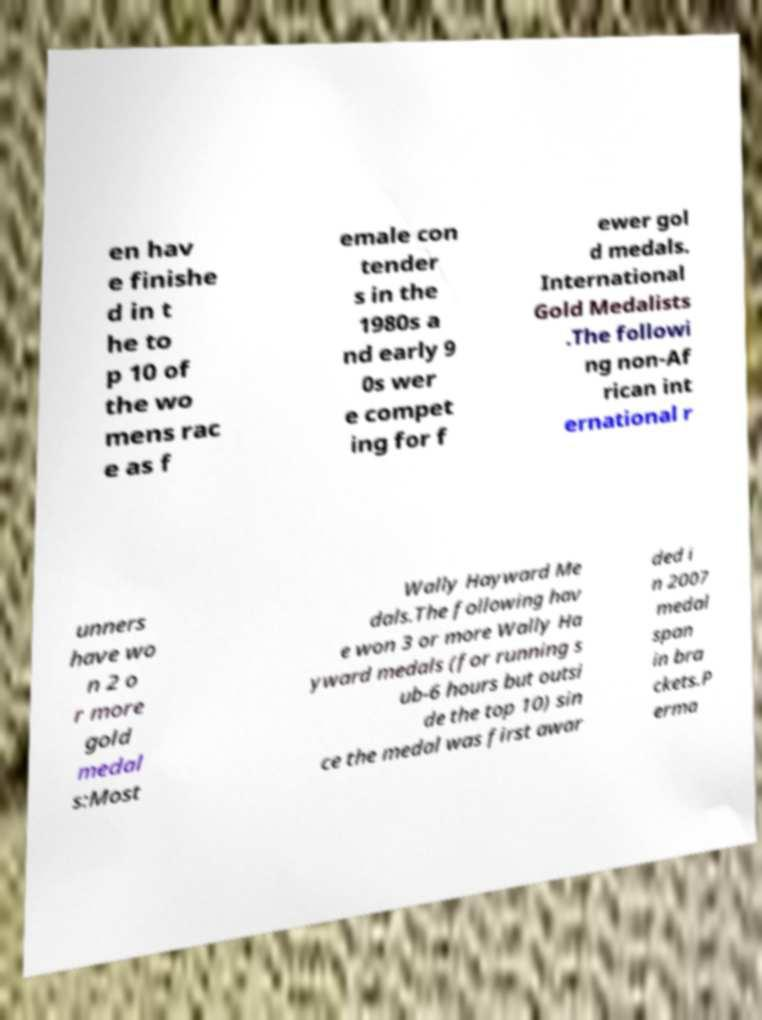Can you read and provide the text displayed in the image?This photo seems to have some interesting text. Can you extract and type it out for me? en hav e finishe d in t he to p 10 of the wo mens rac e as f emale con tender s in the 1980s a nd early 9 0s wer e compet ing for f ewer gol d medals. International Gold Medalists .The followi ng non-Af rican int ernational r unners have wo n 2 o r more gold medal s:Most Wally Hayward Me dals.The following hav e won 3 or more Wally Ha yward medals (for running s ub-6 hours but outsi de the top 10) sin ce the medal was first awar ded i n 2007 medal span in bra ckets.P erma 